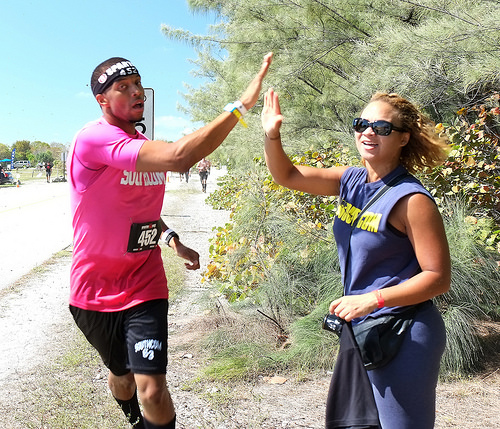<image>
Can you confirm if the brush is next to the woman? Yes. The brush is positioned adjacent to the woman, located nearby in the same general area. 